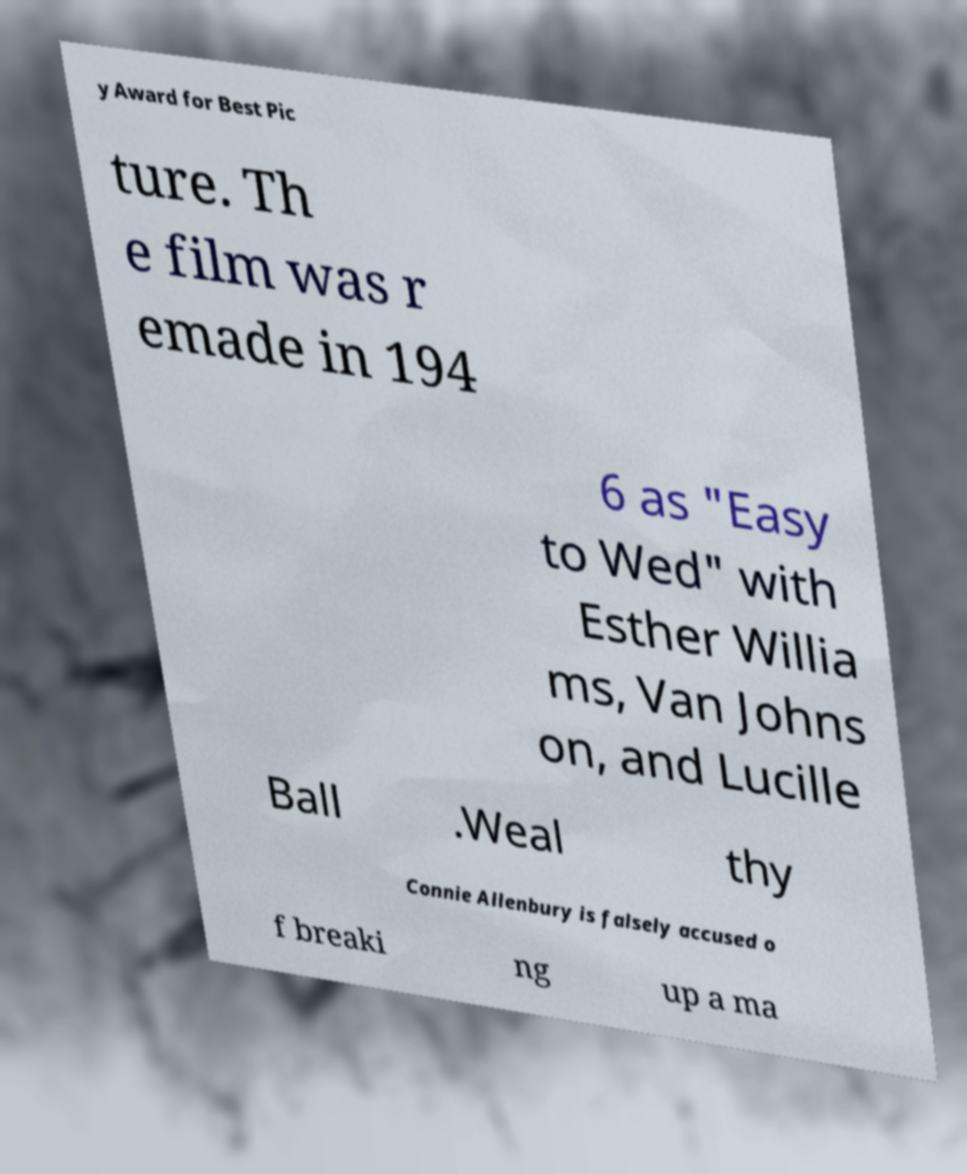For documentation purposes, I need the text within this image transcribed. Could you provide that? y Award for Best Pic ture. Th e film was r emade in 194 6 as "Easy to Wed" with Esther Willia ms, Van Johns on, and Lucille Ball .Weal thy Connie Allenbury is falsely accused o f breaki ng up a ma 